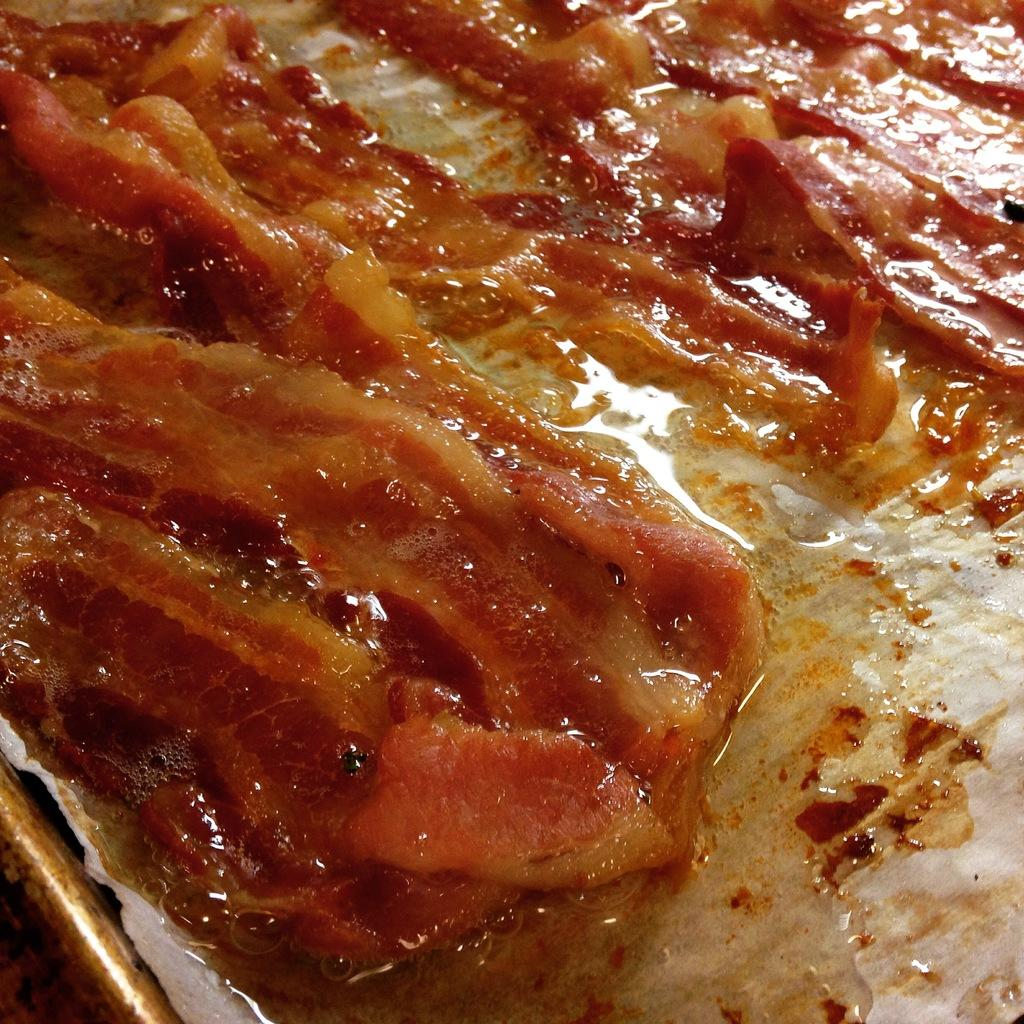What can be seen in the image related to food? There is food in the image. Can you describe the location of the plate in the image? The plate is at the bottom left of the image. What type of daughter can be seen interacting with the food in the image? There is no daughter present in the image, and therefore no such interaction can be observed. 